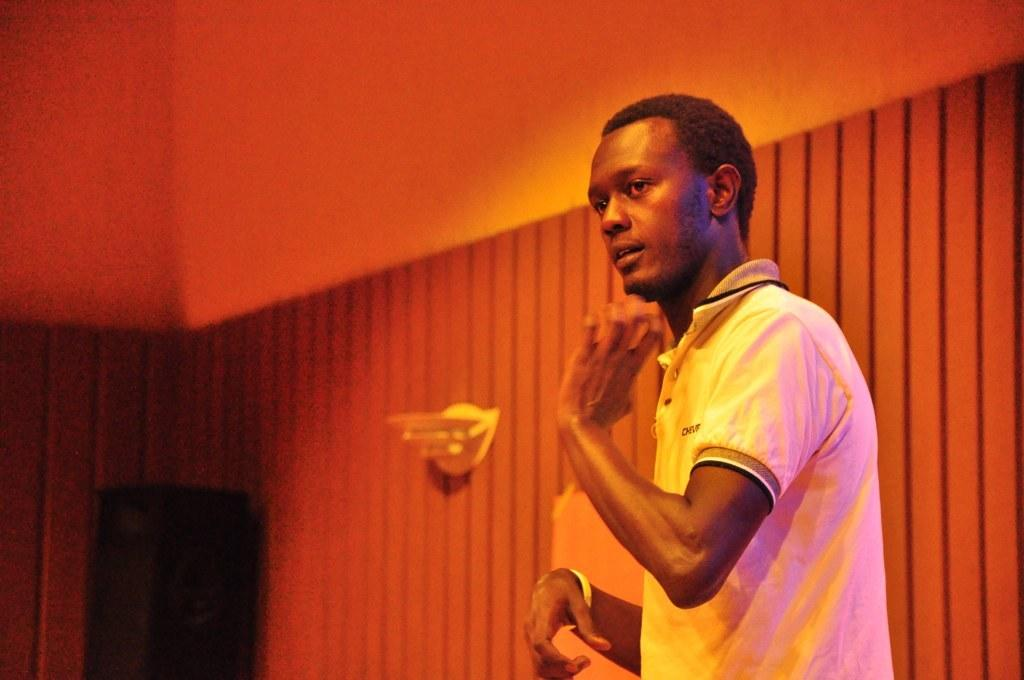What is the main subject of the image? There is a person in the image. What is the person doing in the image? The person is standing on a surface. What type of bell can be heard ringing in the image? There is no bell present in the image, and therefore no sound can be heard. 